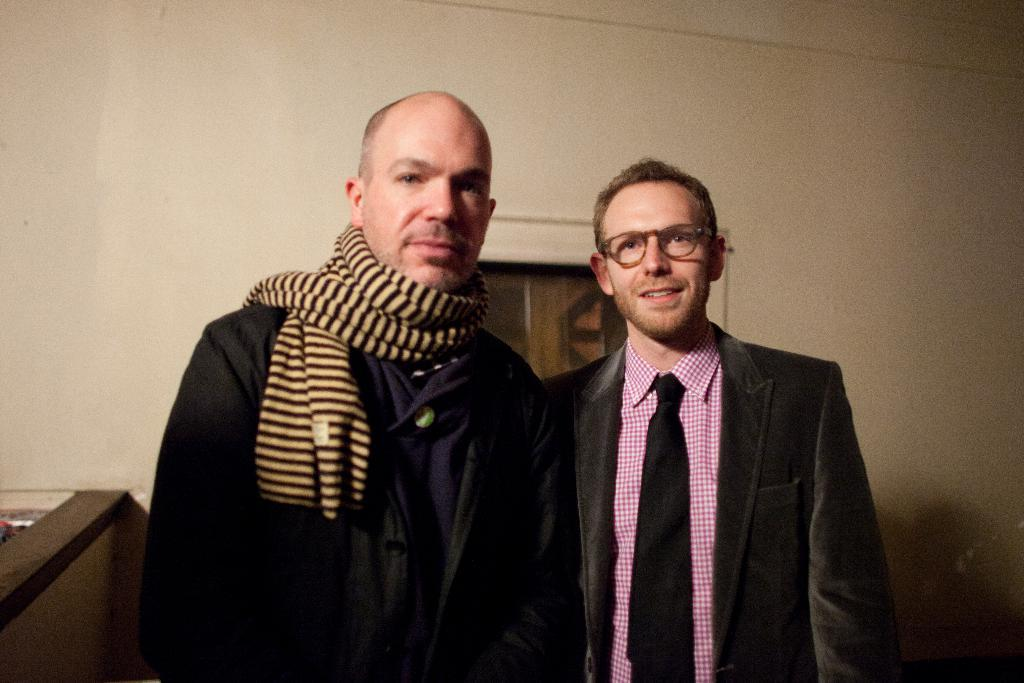How many people are in the image? There are two people in the image. What are the people doing in the image? The two people are standing near a wall. What can be seen near the wall? There is an object near the wall. What type of window is visible in the image? There is a wooden window visible at the backside of the people. What type of jeans is the butter wearing in the image? There is no butter or jeans present in the image. How many pears can be seen hanging from the wooden window? There are no pears visible in the image; only the wooden window is present. 